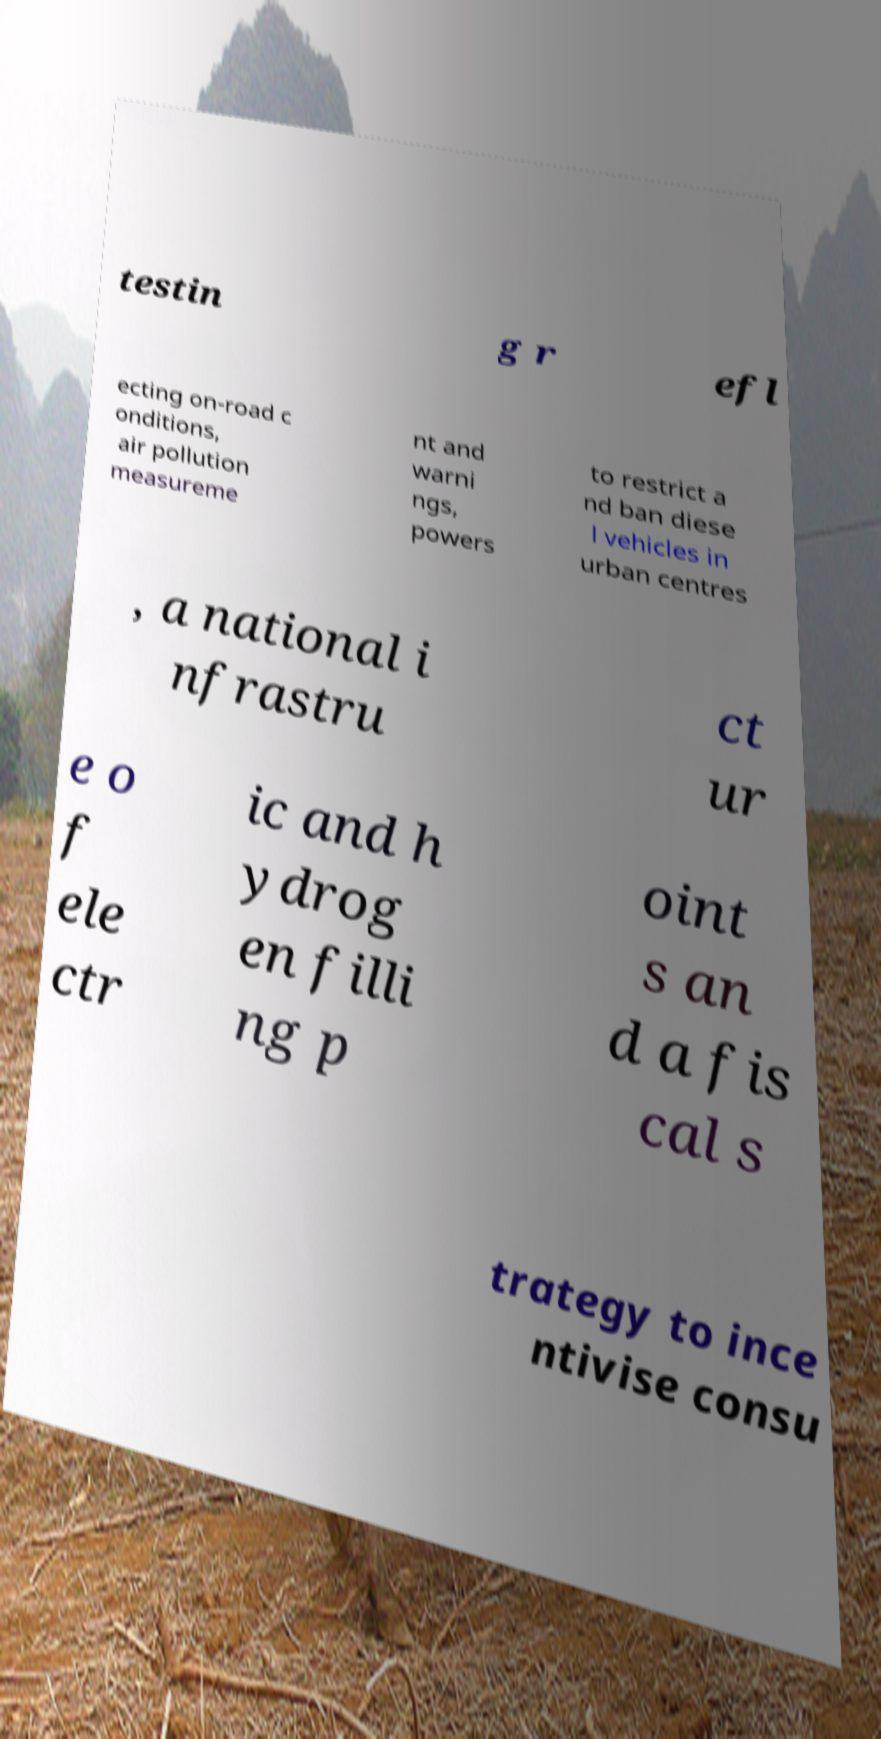Could you assist in decoding the text presented in this image and type it out clearly? testin g r efl ecting on-road c onditions, air pollution measureme nt and warni ngs, powers to restrict a nd ban diese l vehicles in urban centres , a national i nfrastru ct ur e o f ele ctr ic and h ydrog en filli ng p oint s an d a fis cal s trategy to ince ntivise consu 